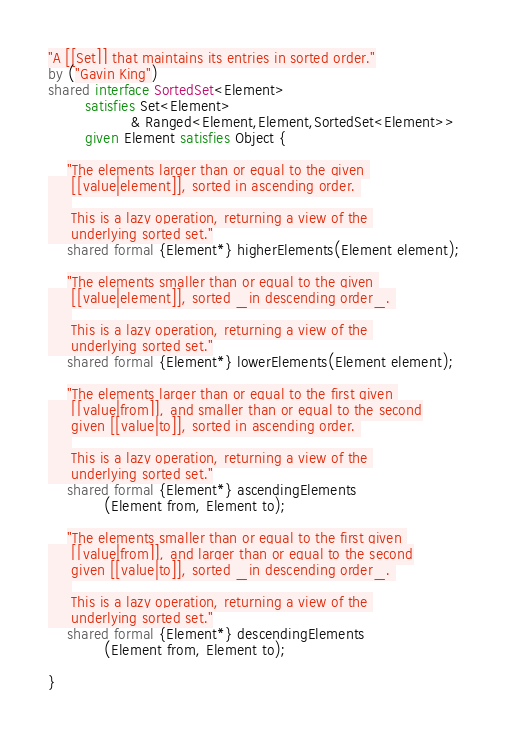Convert code to text. <code><loc_0><loc_0><loc_500><loc_500><_Ceylon_>"A [[Set]] that maintains its entries in sorted order."
by ("Gavin King")
shared interface SortedSet<Element>
        satisfies Set<Element> 
                  & Ranged<Element,Element,SortedSet<Element>>
        given Element satisfies Object {
    
    "The elements larger than or equal to the given 
     [[value|element]], sorted in ascending order. 
     
     This is a lazy operation, returning a view of the 
     underlying sorted set."
    shared formal {Element*} higherElements(Element element);
    
    "The elements smaller than or equal to the given 
     [[value|element]], sorted _in descending order_. 
     
     This is a lazy operation, returning a view of the 
     underlying sorted set."
    shared formal {Element*} lowerElements(Element element);
    
    "The elements larger than or equal to the first given 
     [[value|from]], and smaller than or equal to the second
     given [[value|to]], sorted in ascending order. 
     
     This is a lazy operation, returning a view of the 
     underlying sorted set."
    shared formal {Element*} ascendingElements
            (Element from, Element to);
    
    "The elements smaller than or equal to the first given 
     [[value|from]], and larger than or equal to the second
     given [[value|to]], sorted _in descending order_. 
     
     This is a lazy operation, returning a view of the 
     underlying sorted set."
    shared formal {Element*} descendingElements
            (Element from, Element to);
    
}

</code> 